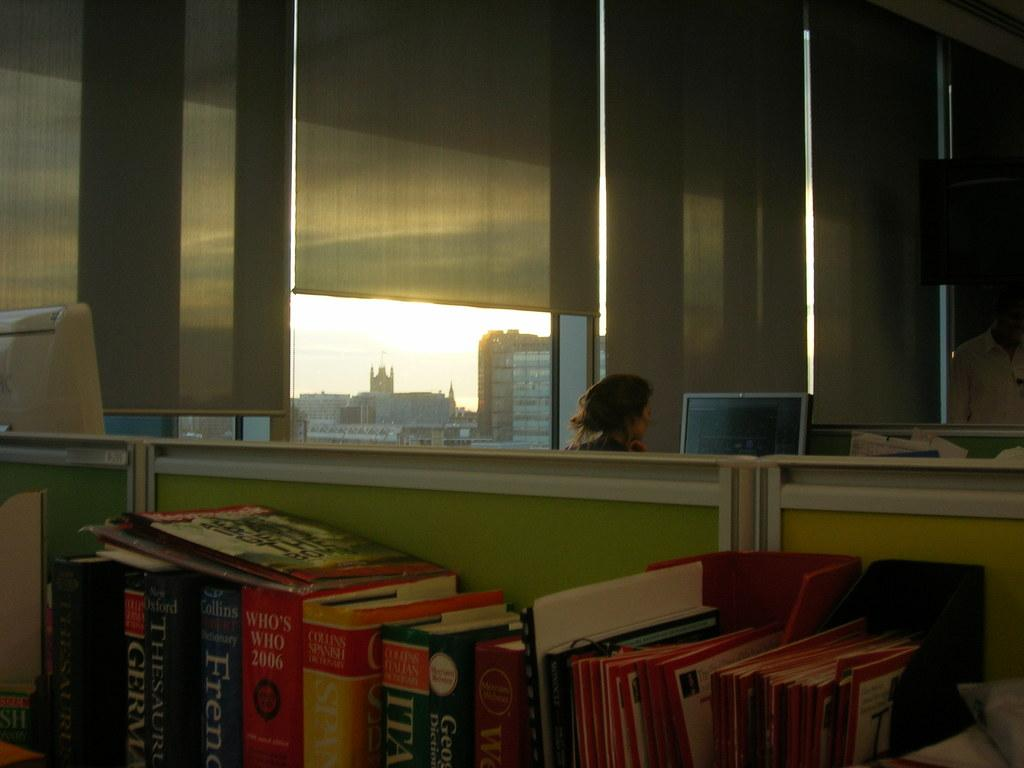Provide a one-sentence caption for the provided image. A bunch of books on a table, one called Who's Who 2006. 